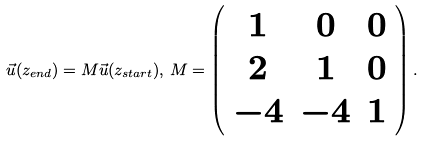<formula> <loc_0><loc_0><loc_500><loc_500>\vec { u } ( z _ { e n d } ) = M \vec { u } ( z _ { s t a r t } ) , \, M = \left ( \begin{array} { c c c } 1 & 0 & 0 \\ 2 & 1 & 0 \\ - 4 & - 4 & 1 \end{array} \right ) .</formula> 